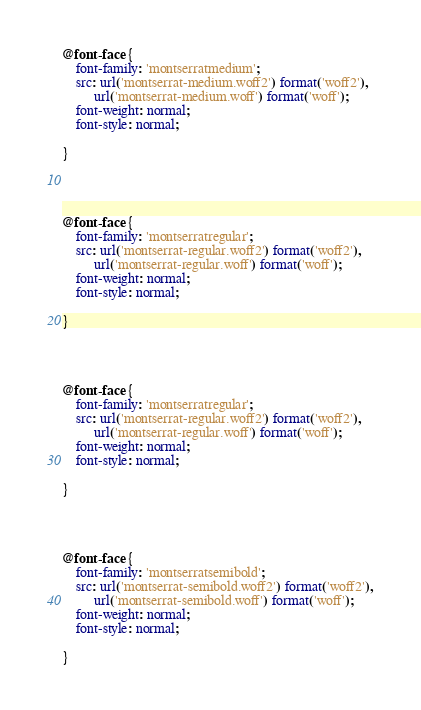<code> <loc_0><loc_0><loc_500><loc_500><_CSS_>



@font-face {
    font-family: 'montserratmedium';
    src: url('montserrat-medium.woff2') format('woff2'),
         url('montserrat-medium.woff') format('woff');
    font-weight: normal;
    font-style: normal;

}




@font-face {
    font-family: 'montserratregular';
    src: url('montserrat-regular.woff2') format('woff2'),
         url('montserrat-regular.woff') format('woff');
    font-weight: normal;
    font-style: normal;

}




@font-face {
    font-family: 'montserratregular';
    src: url('montserrat-regular.woff2') format('woff2'),
         url('montserrat-regular.woff') format('woff');
    font-weight: normal;
    font-style: normal;

}




@font-face {
    font-family: 'montserratsemibold';
    src: url('montserrat-semibold.woff2') format('woff2'),
         url('montserrat-semibold.woff') format('woff');
    font-weight: normal;
    font-style: normal;

}</code> 